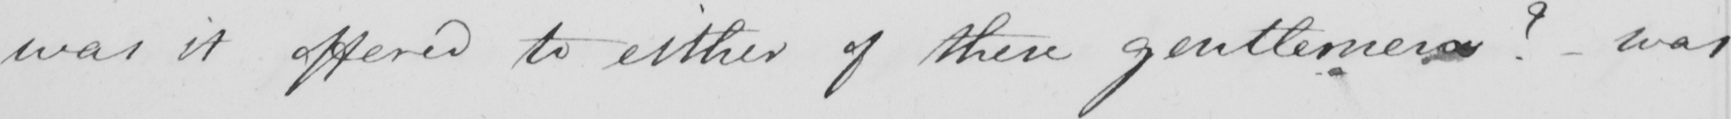Please provide the text content of this handwritten line. was it offered to either of these gentlemen ?   _  was 